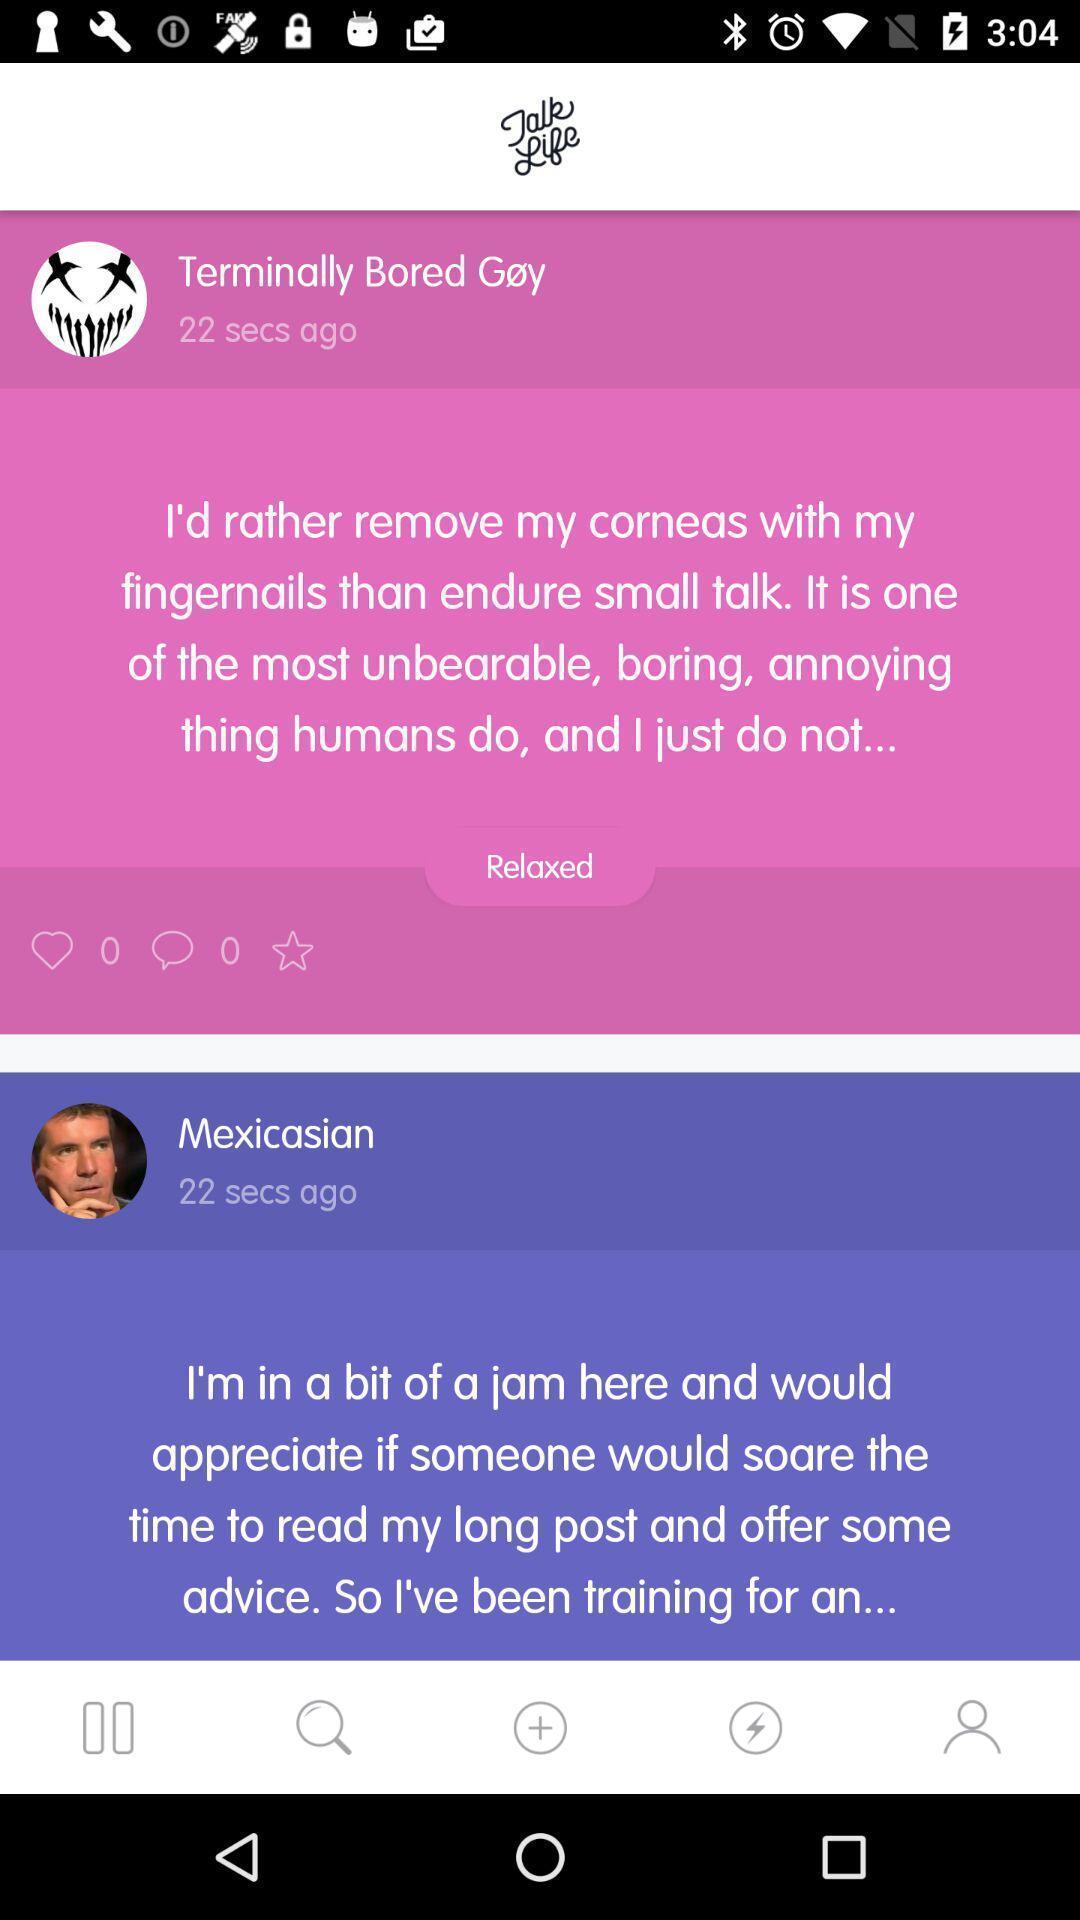Describe this image in words. Screen displaying multiple user profiles information in a social application. 